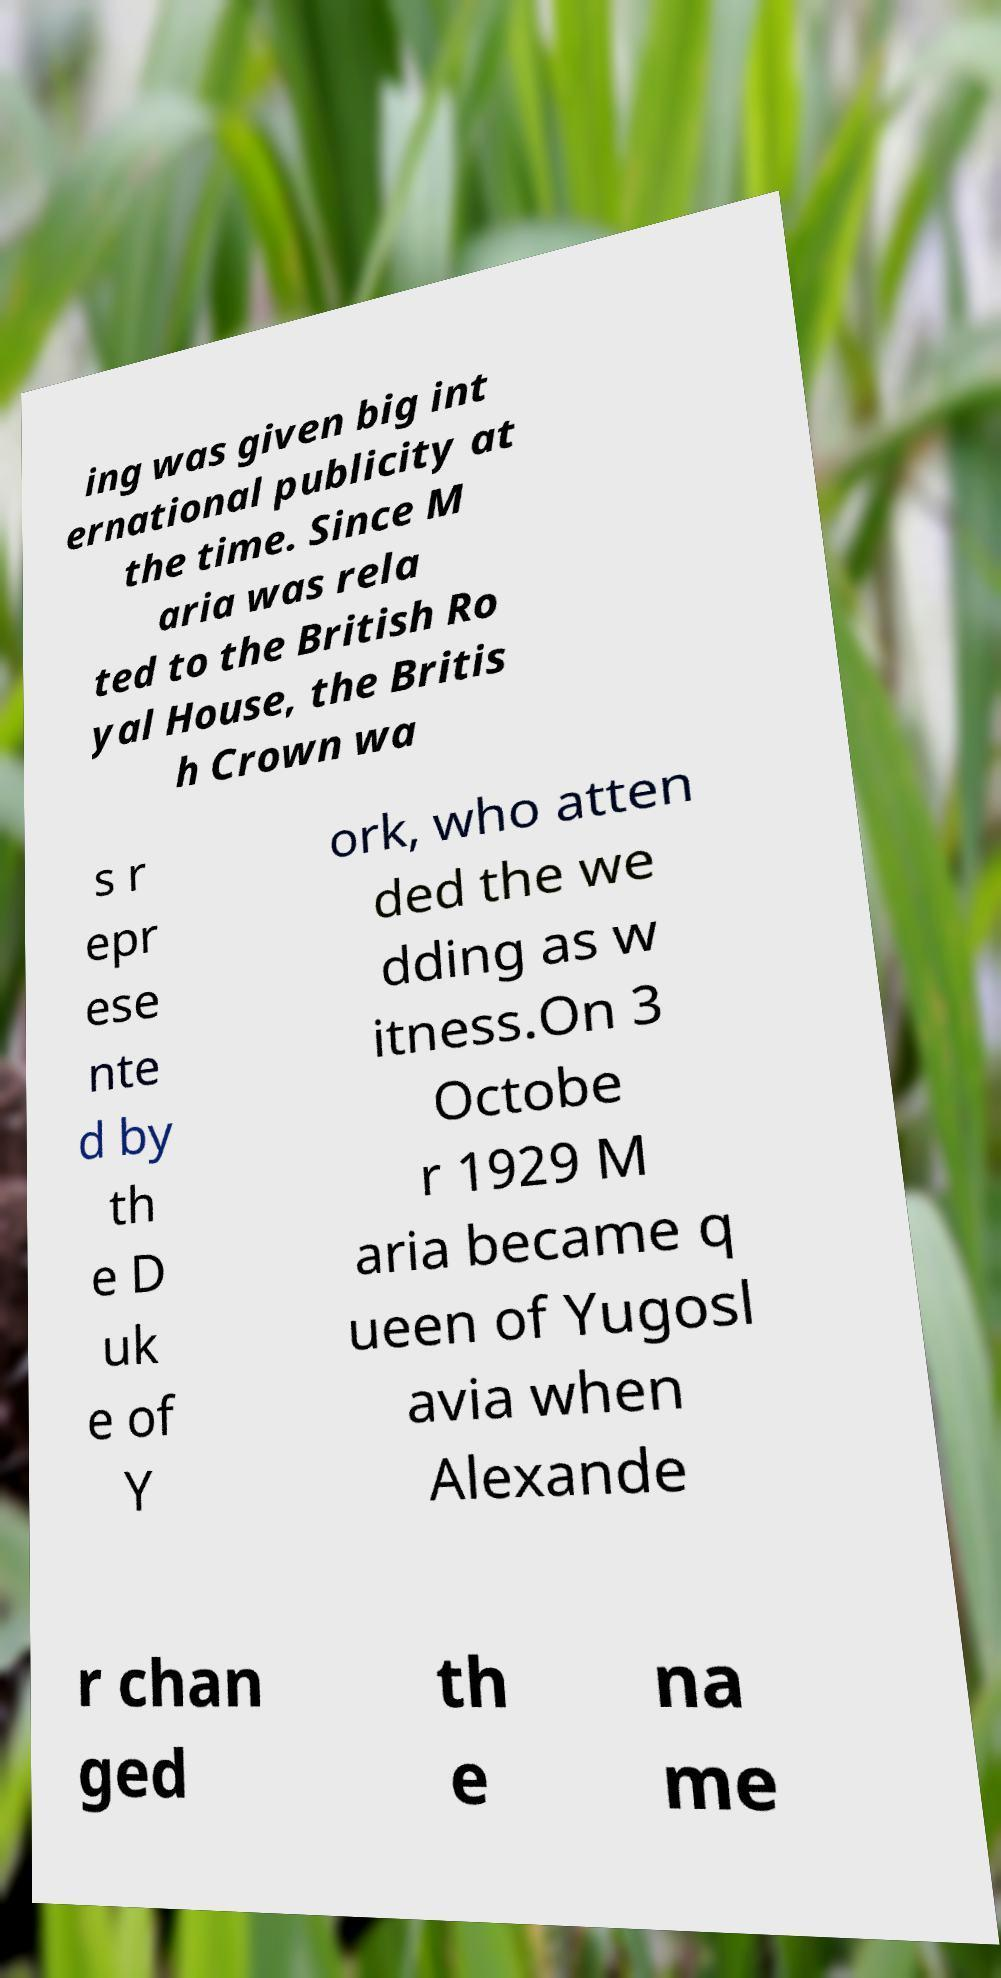For documentation purposes, I need the text within this image transcribed. Could you provide that? ing was given big int ernational publicity at the time. Since M aria was rela ted to the British Ro yal House, the Britis h Crown wa s r epr ese nte d by th e D uk e of Y ork, who atten ded the we dding as w itness.On 3 Octobe r 1929 M aria became q ueen of Yugosl avia when Alexande r chan ged th e na me 